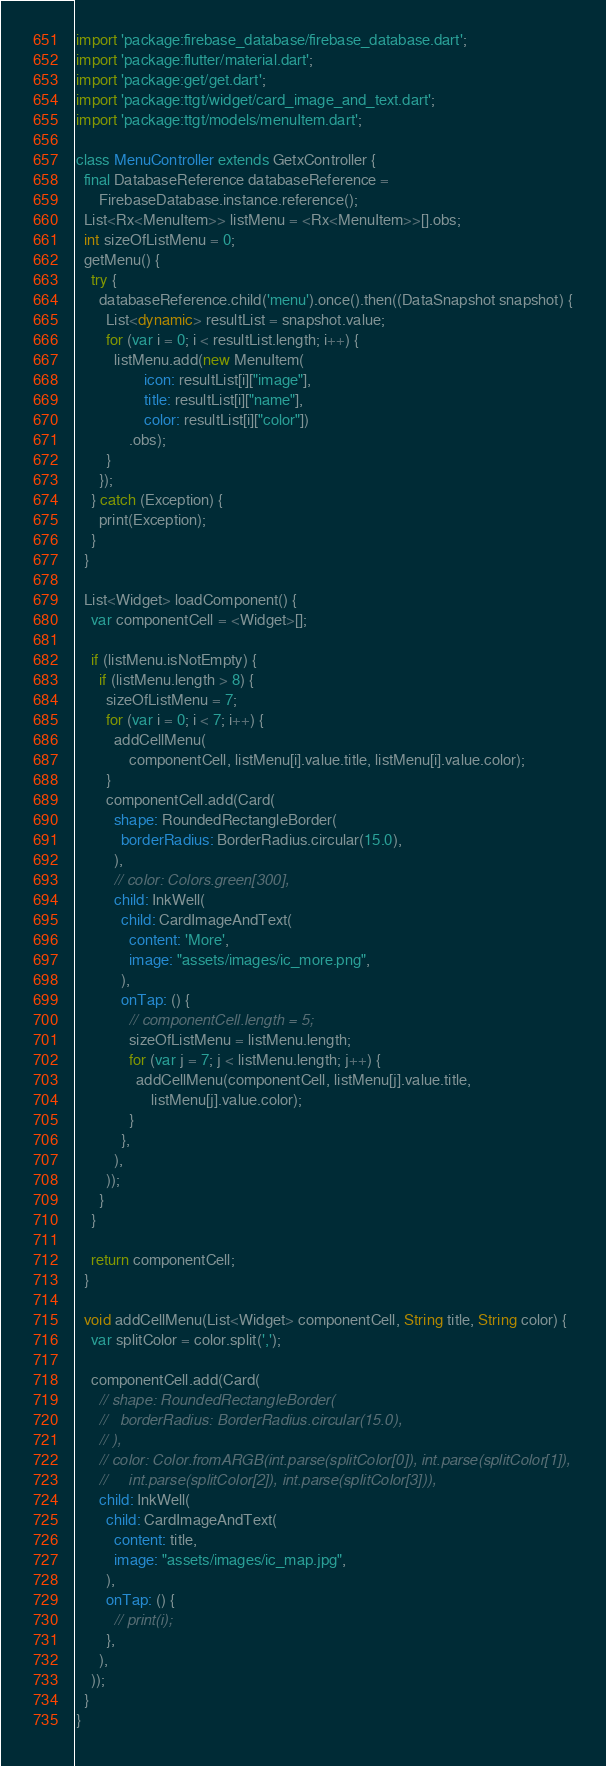Convert code to text. <code><loc_0><loc_0><loc_500><loc_500><_Dart_>import 'package:firebase_database/firebase_database.dart';
import 'package:flutter/material.dart';
import 'package:get/get.dart';
import 'package:ttgt/widget/card_image_and_text.dart';
import 'package:ttgt/models/menuItem.dart';

class MenuController extends GetxController {
  final DatabaseReference databaseReference =
      FirebaseDatabase.instance.reference();
  List<Rx<MenuItem>> listMenu = <Rx<MenuItem>>[].obs;
  int sizeOfListMenu = 0;
  getMenu() {
    try {
      databaseReference.child('menu').once().then((DataSnapshot snapshot) {
        List<dynamic> resultList = snapshot.value;
        for (var i = 0; i < resultList.length; i++) {
          listMenu.add(new MenuItem(
                  icon: resultList[i]["image"],
                  title: resultList[i]["name"],
                  color: resultList[i]["color"])
              .obs);
        }
      });
    } catch (Exception) {
      print(Exception);
    }
  }

  List<Widget> loadComponent() {
    var componentCell = <Widget>[];

    if (listMenu.isNotEmpty) {
      if (listMenu.length > 8) {
        sizeOfListMenu = 7;
        for (var i = 0; i < 7; i++) {
          addCellMenu(
              componentCell, listMenu[i].value.title, listMenu[i].value.color);
        }
        componentCell.add(Card(
          shape: RoundedRectangleBorder(
            borderRadius: BorderRadius.circular(15.0),
          ),
          // color: Colors.green[300],
          child: InkWell(
            child: CardImageAndText(
              content: 'More',
              image: "assets/images/ic_more.png",
            ),
            onTap: () {
              // componentCell.length = 5;
              sizeOfListMenu = listMenu.length;
              for (var j = 7; j < listMenu.length; j++) {
                addCellMenu(componentCell, listMenu[j].value.title,
                    listMenu[j].value.color);
              }
            },
          ),
        ));
      }
    }

    return componentCell;
  }

  void addCellMenu(List<Widget> componentCell, String title, String color) {
    var splitColor = color.split(',');

    componentCell.add(Card(
      // shape: RoundedRectangleBorder(
      //   borderRadius: BorderRadius.circular(15.0),
      // ),
      // color: Color.fromARGB(int.parse(splitColor[0]), int.parse(splitColor[1]),
      //     int.parse(splitColor[2]), int.parse(splitColor[3])),
      child: InkWell(
        child: CardImageAndText(
          content: title,
          image: "assets/images/ic_map.jpg",
        ),
        onTap: () {
          // print(i);
        },
      ),
    ));
  }
}
</code> 